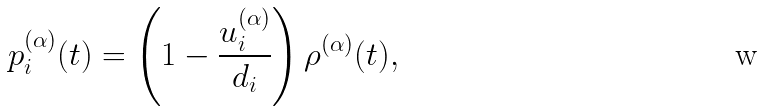<formula> <loc_0><loc_0><loc_500><loc_500>p _ { i } ^ { ( \alpha ) } ( t ) = \left ( 1 - \frac { u _ { i } ^ { ( \alpha ) } } { d _ { i } } \right ) \rho ^ { ( \alpha ) } ( t ) ,</formula> 